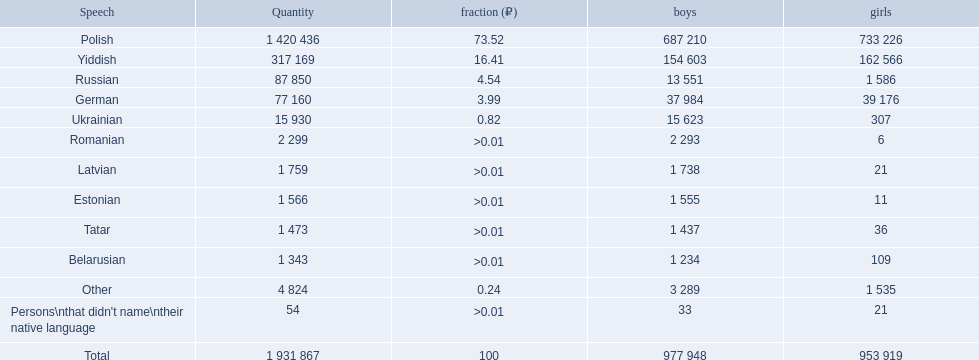What are all the spoken languages? Polish, Yiddish, Russian, German, Ukrainian, Romanian, Latvian, Estonian, Tatar, Belarusian. Which one of these has the most people speaking it? Polish. How many languages are shown? Polish, Yiddish, Russian, German, Ukrainian, Romanian, Latvian, Estonian, Tatar, Belarusian, Other. Can you parse all the data within this table? {'header': ['Speech', 'Quantity', 'fraction (₽)', 'boys', 'girls'], 'rows': [['Polish', '1 420 436', '73.52', '687 210', '733 226'], ['Yiddish', '317 169', '16.41', '154 603', '162 566'], ['Russian', '87 850', '4.54', '13 551', '1 586'], ['German', '77 160', '3.99', '37 984', '39 176'], ['Ukrainian', '15 930', '0.82', '15 623', '307'], ['Romanian', '2 299', '>0.01', '2 293', '6'], ['Latvian', '1 759', '>0.01', '1 738', '21'], ['Estonian', '1 566', '>0.01', '1 555', '11'], ['Tatar', '1 473', '>0.01', '1 437', '36'], ['Belarusian', '1 343', '>0.01', '1 234', '109'], ['Other', '4 824', '0.24', '3 289', '1 535'], ["Persons\\nthat didn't name\\ntheir native language", '54', '>0.01', '33', '21'], ['Total', '1 931 867', '100', '977 948', '953 919']]} What language is in third place? Russian. What language is the most spoken after that one? German. 